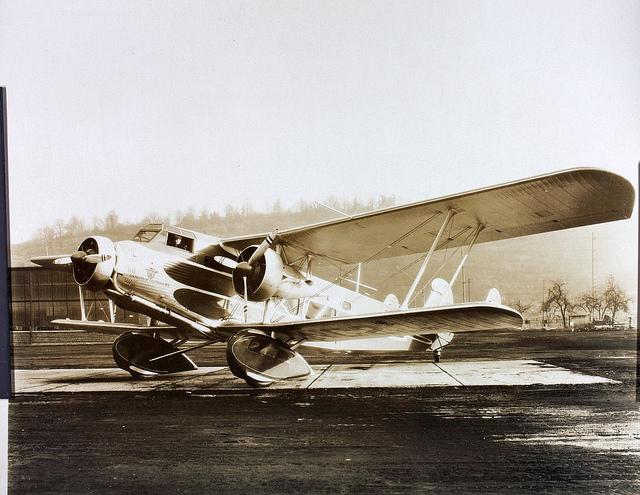What type of plane is shown?
Give a very brief answer. Old. Is the sky clear?
Be succinct. Yes. Does this plane have propellers or turbines?
Be succinct. Propellers. 